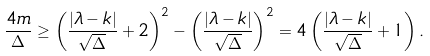Convert formula to latex. <formula><loc_0><loc_0><loc_500><loc_500>\frac { 4 m } { \Delta } \geq \left ( \frac { | \lambda - k | } { \sqrt { \Delta } } + 2 \right ) ^ { 2 } - \left ( \frac { | \lambda - k | } { \sqrt { \Delta } } \right ) ^ { 2 } = 4 \left ( \frac { | \lambda - k | } { \sqrt { \Delta } } + 1 \right ) .</formula> 